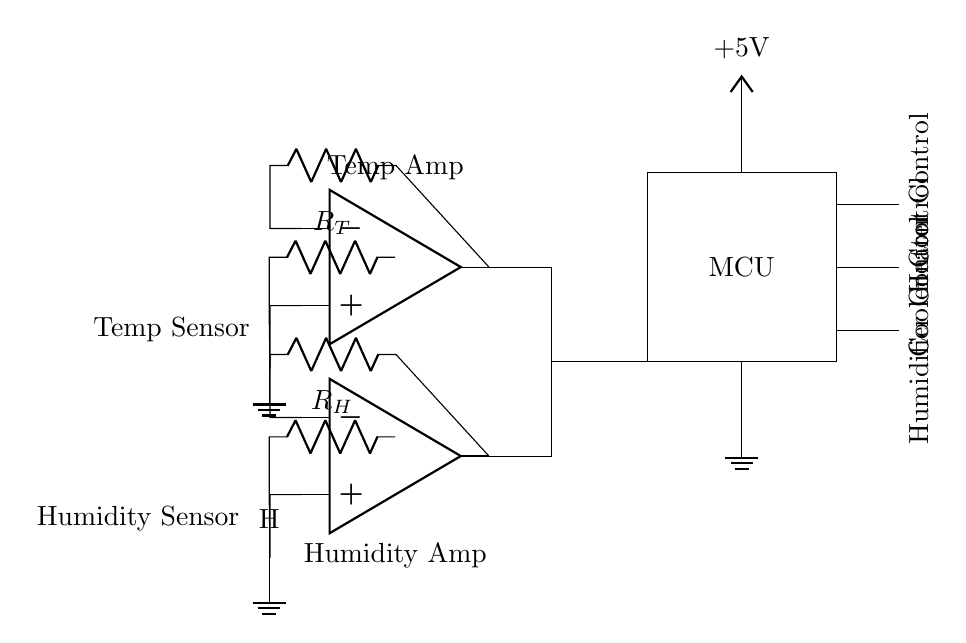What is the power supply voltage? The power supply voltage is indicated in the circuit as +5V. This is shown next to the Vcc node connected above the microcontroller.
Answer: 5V What do the rectangles labeled 'MCU' represent? The rectangles labeled 'MCU' represent the microcontroller unit in the circuit that processes the signals from the temperature and humidity sensors.
Answer: Microcontroller How many amplifiers are in this circuit? There are two operational amplifiers in the circuit. One is connected to the temperature sensor and the other to the humidity sensor.
Answer: Two What type of sensor is connected at the top of the circuit? The circuit shows a temperature sensor at the top, which is connected to the first operational amplifier.
Answer: Temperature sensor What is the output control for humidity adjustments? The output control for humidity adjustments is labeled as 'Humidifier Control' in the circuit, indicating that this control is dedicated to regulating humidity.
Answer: Humidifier Control Explain the purpose of the operational amplifiers in this circuit. The operational amplifiers serve to amplify the signals coming from the temperature and humidity sensors. They take the low-level signals from the sensors and provide stronger output signals to be read by the microcontroller. This amplification improves the accuracy of the readings.
Answer: Amplification of sensor signals 